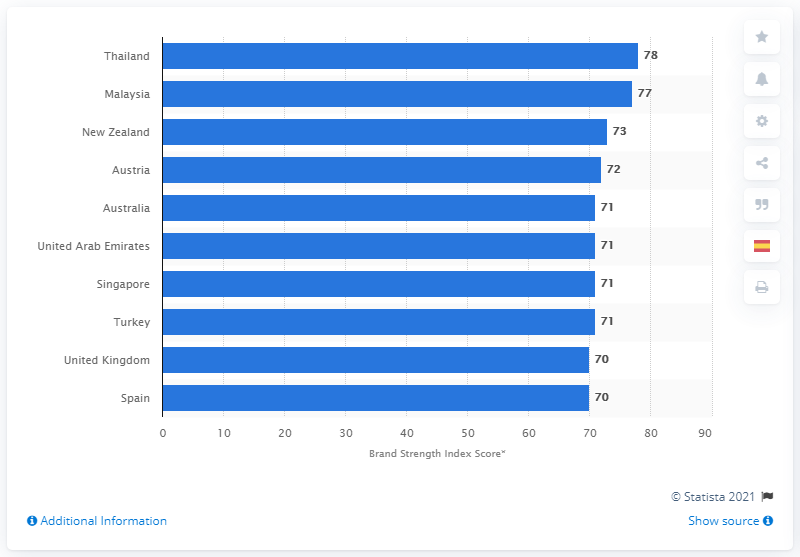Draw attention to some important aspects in this diagram. In 2014, Thailand's tourism segment score was 78. 